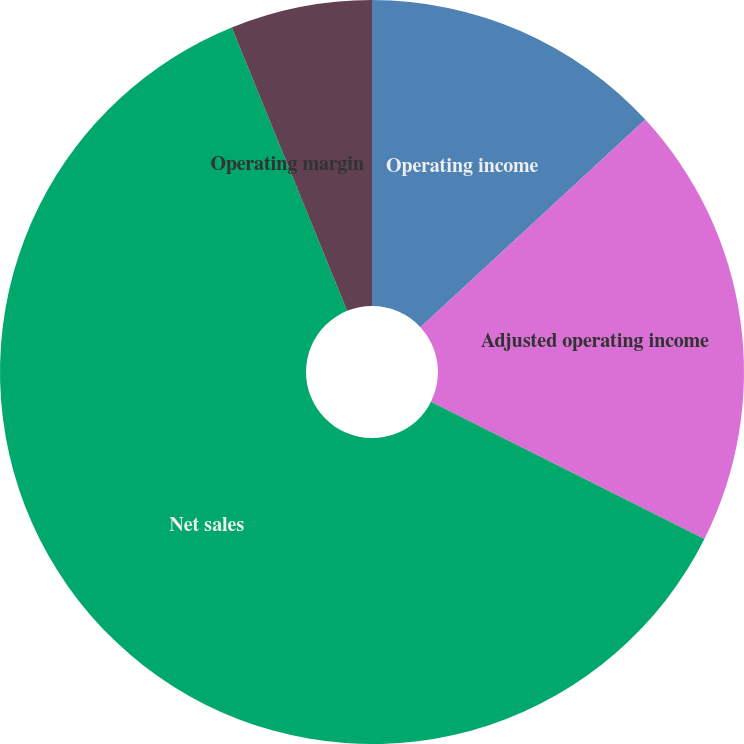Convert chart. <chart><loc_0><loc_0><loc_500><loc_500><pie_chart><fcel>Operating income<fcel>Adjusted operating income<fcel>Net sales<fcel>Operating margin<fcel>Adjusted operating margin<nl><fcel>13.13%<fcel>19.28%<fcel>61.44%<fcel>0.0%<fcel>6.15%<nl></chart> 